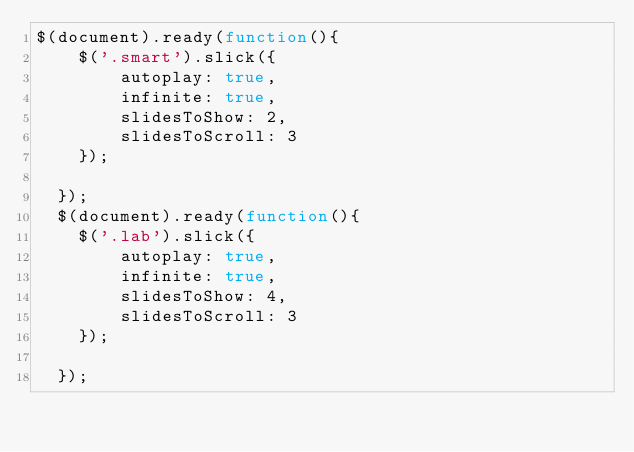Convert code to text. <code><loc_0><loc_0><loc_500><loc_500><_JavaScript_>$(document).ready(function(){
    $('.smart').slick({
        autoplay: true,
        infinite: true,
        slidesToShow: 2,
        slidesToScroll: 3
    });
   
  });
  $(document).ready(function(){
    $('.lab').slick({
        autoplay: true,
        infinite: true,
        slidesToShow: 4,
        slidesToScroll: 3
    });
   
  });
</code> 